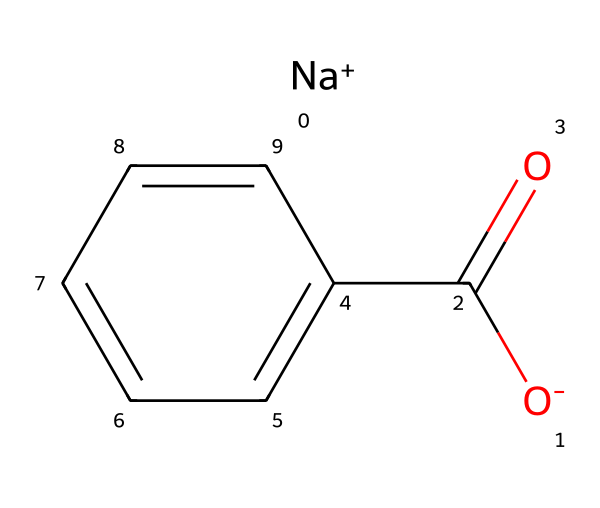What is the molecular formula of sodium benzoate? To derive the molecular formula from the SMILES representation, we identify the atoms present: there is one sodium (Na) atom, one carbon (C) atom in the carboxylate (C=O) group, six carbon atoms from the benzene ring, and two oxygen (O) atoms. Therefore, the molecular formula is NaC7H5O2.
Answer: NaC7H5O2 How many carbon atoms are in sodium benzoate? Upon examining the chemical structure, we see one carbon atom in the carboxylate group and six in the benzene ring, totaling seven carbon atoms.
Answer: 7 What type of functional group is present in sodium benzoate? The structure contains a carboxylate group (C(=O)O-), characterized by a carbon double-bonded to an oxygen atom and singly bonded to another oxygen that carries a negative charge. This is typical for salts derived from carboxylic acids.
Answer: carboxylate What is the significance of the sodium ion in sodium benzoate? The presence of the sodium ion indicates that sodium benzoate is the sodium salt of benzoic acid, which enhances its solubility in water and acts as a preservative, helping to inhibit microbial growth in sports drinks.
Answer: enhances solubility What type of compound is sodium benzoate classified as? Sodium benzoate is classified as a preservative due to its ability to inhibit the growth of bacteria and yeast, thus prolonging the shelf life of products, including sports drinks.
Answer: preservative What is the charge on the oxygen atom in the carboxylate group of sodium benzoate? The oxygen in the carboxylate group carries a negative charge, as indicated by the O- in the SMILES representation. This negative charge results from the deprotonation of the carboxylic acid, creating the salt.
Answer: negative How does the benzene ring contribute to the properties of sodium benzoate? The benzene ring contributes to the chemical's hydrophobic character, which helps in maintaining the stability of the compound in various formulations. The presence of the aromatic structure plays a role in its effectiveness as a preservative.
Answer: stability 